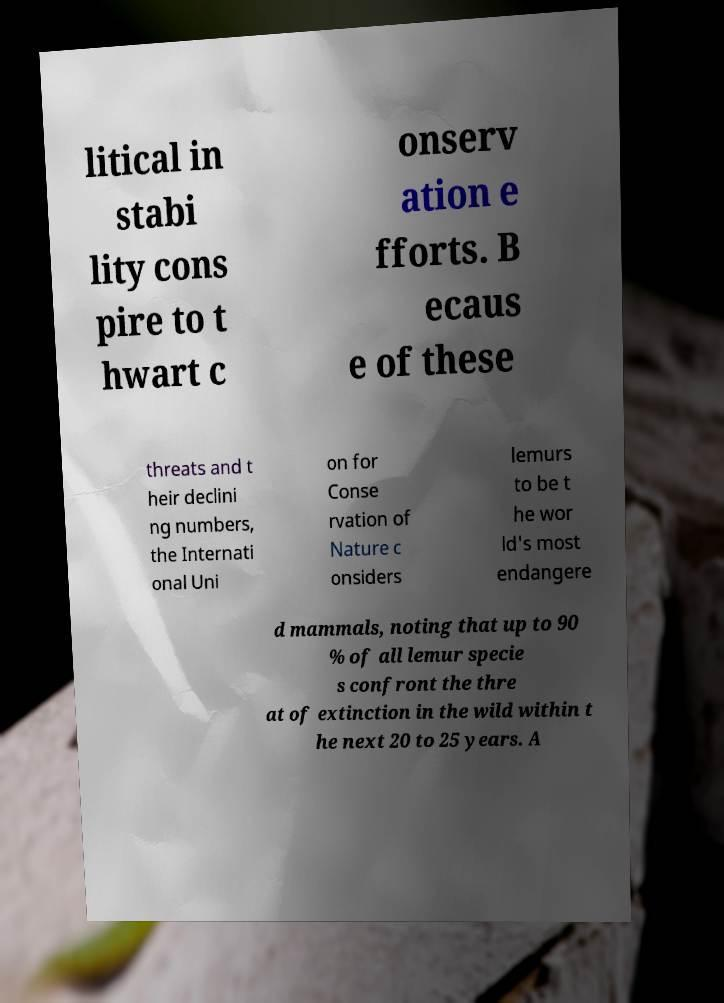Please identify and transcribe the text found in this image. litical in stabi lity cons pire to t hwart c onserv ation e fforts. B ecaus e of these threats and t heir declini ng numbers, the Internati onal Uni on for Conse rvation of Nature c onsiders lemurs to be t he wor ld's most endangere d mammals, noting that up to 90 % of all lemur specie s confront the thre at of extinction in the wild within t he next 20 to 25 years. A 